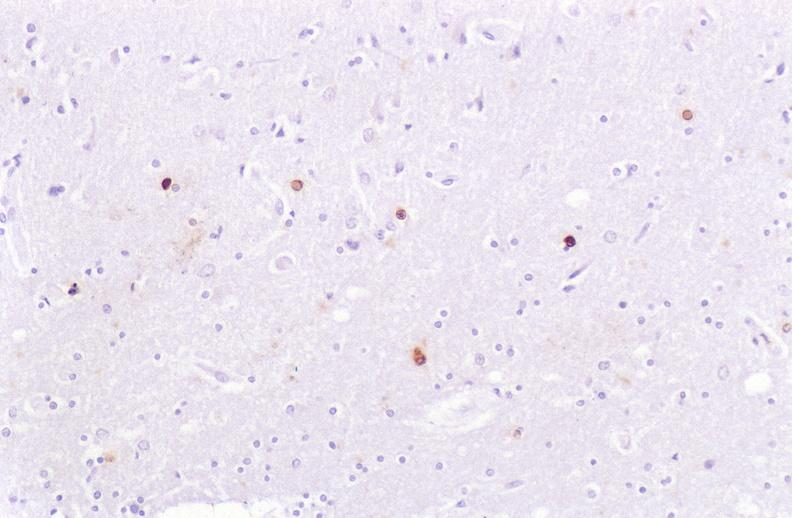s nervous present?
Answer the question using a single word or phrase. Yes 